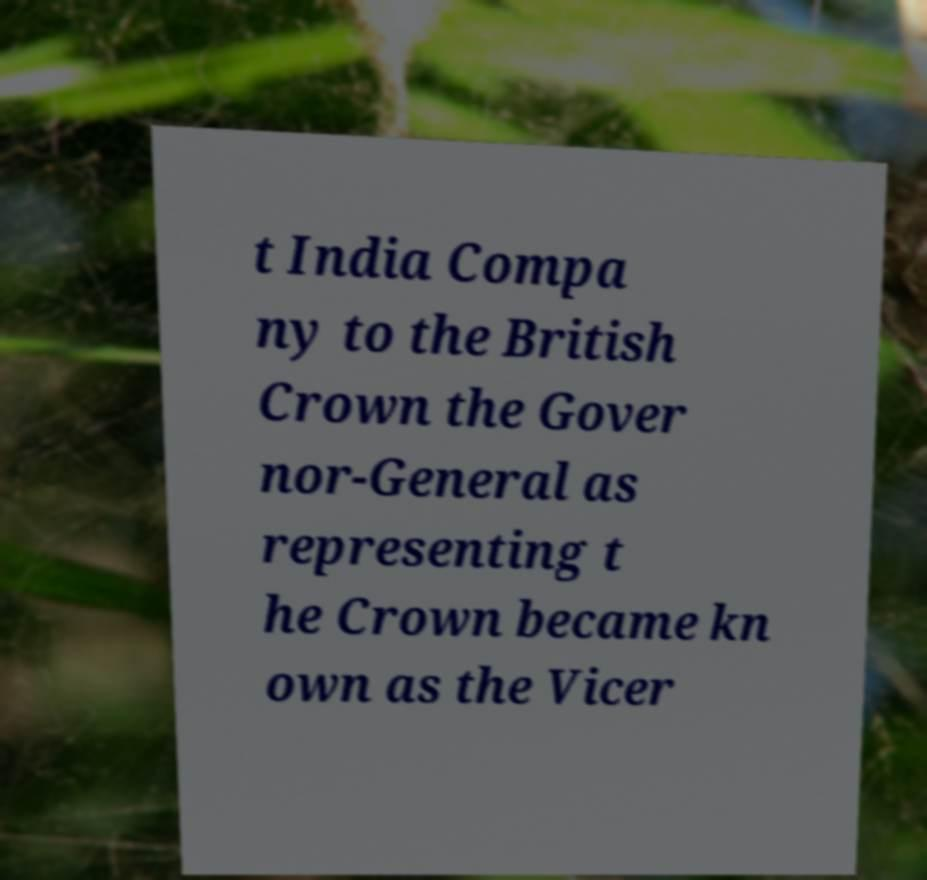Can you read and provide the text displayed in the image?This photo seems to have some interesting text. Can you extract and type it out for me? t India Compa ny to the British Crown the Gover nor-General as representing t he Crown became kn own as the Vicer 